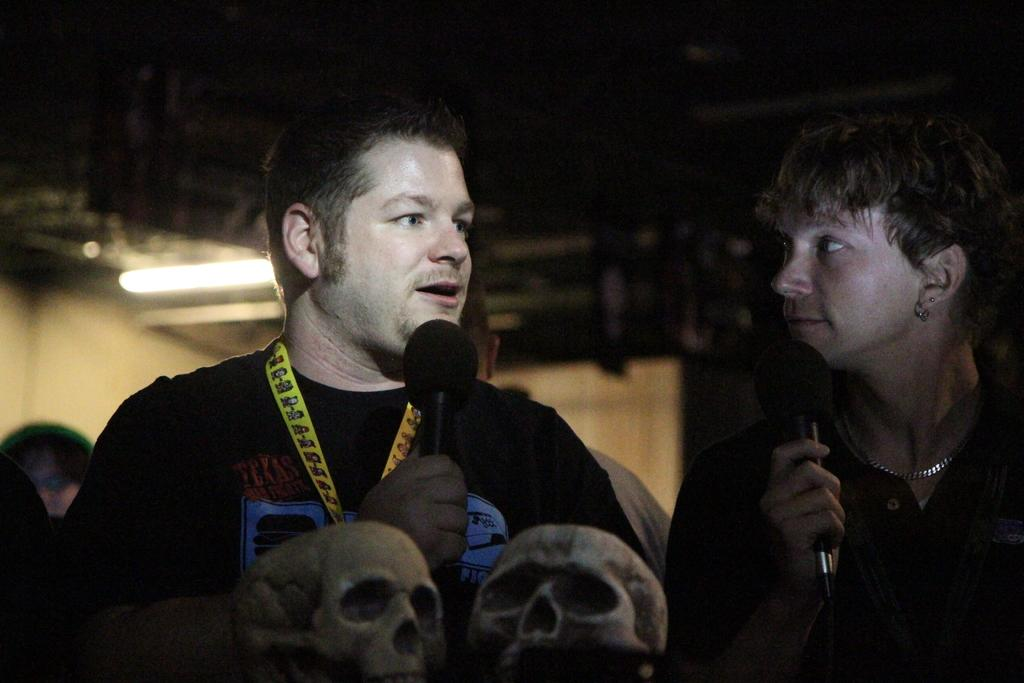How many people are in the image? There are two people in the image. What are the two people holding in their hands? The two people are holding microphones. What can be seen in the front of the image? There are two skeleton heads in the front of the image. What type of furniture is being used by the people in the image? There is no furniture visible in the image. Can you tell me how the people are expressing anger in the image? There is no indication of anger in the image; the people are holding microphones. 